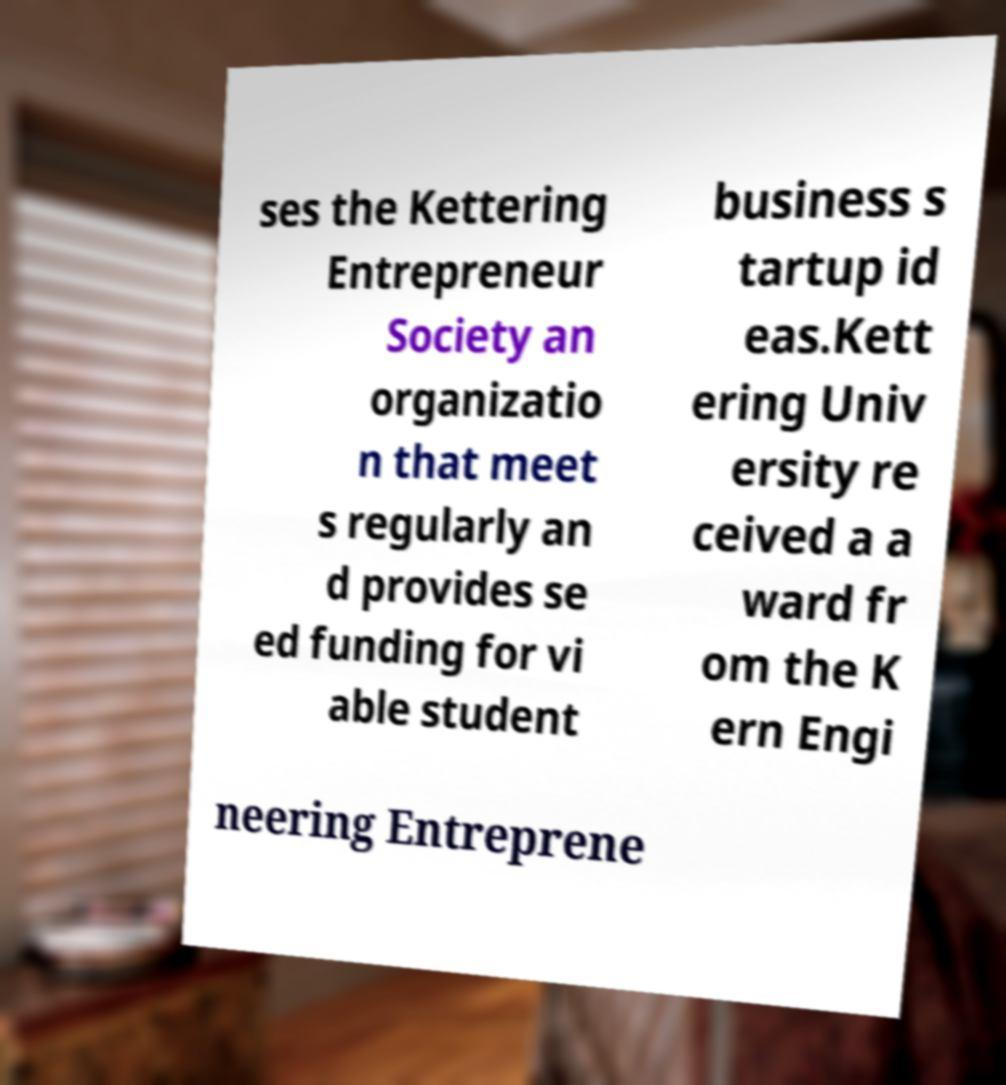Could you extract and type out the text from this image? ses the Kettering Entrepreneur Society an organizatio n that meet s regularly an d provides se ed funding for vi able student business s tartup id eas.Kett ering Univ ersity re ceived a a ward fr om the K ern Engi neering Entreprene 